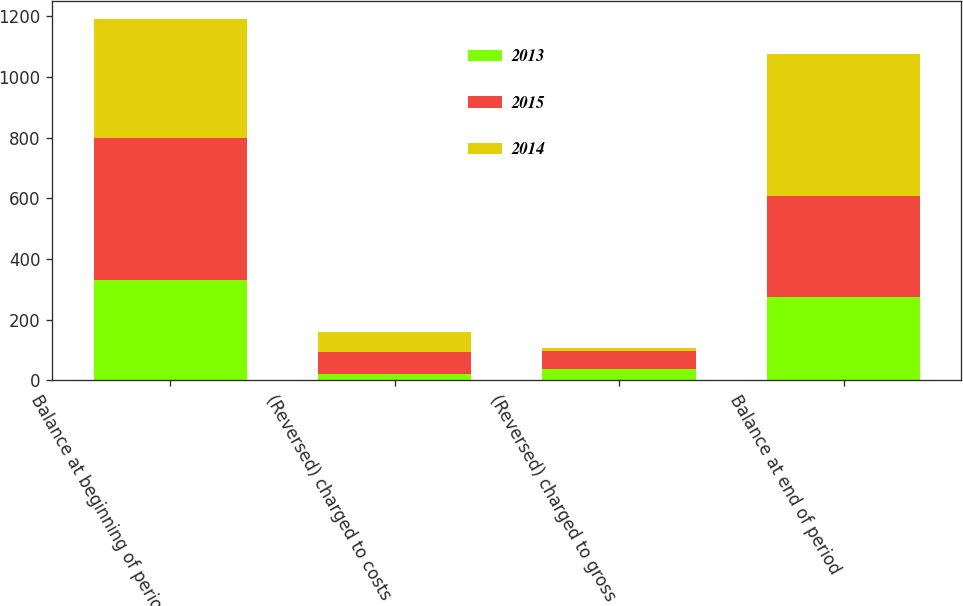Convert chart. <chart><loc_0><loc_0><loc_500><loc_500><stacked_bar_chart><ecel><fcel>Balance at beginning of period<fcel>(Reversed) charged to costs<fcel>(Reversed) charged to gross<fcel>Balance at end of period<nl><fcel>2013<fcel>332.2<fcel>20.8<fcel>36.3<fcel>275.1<nl><fcel>2015<fcel>467.3<fcel>72.8<fcel>62.3<fcel>332.2<nl><fcel>2014<fcel>392.9<fcel>65.2<fcel>9.2<fcel>467.3<nl></chart> 